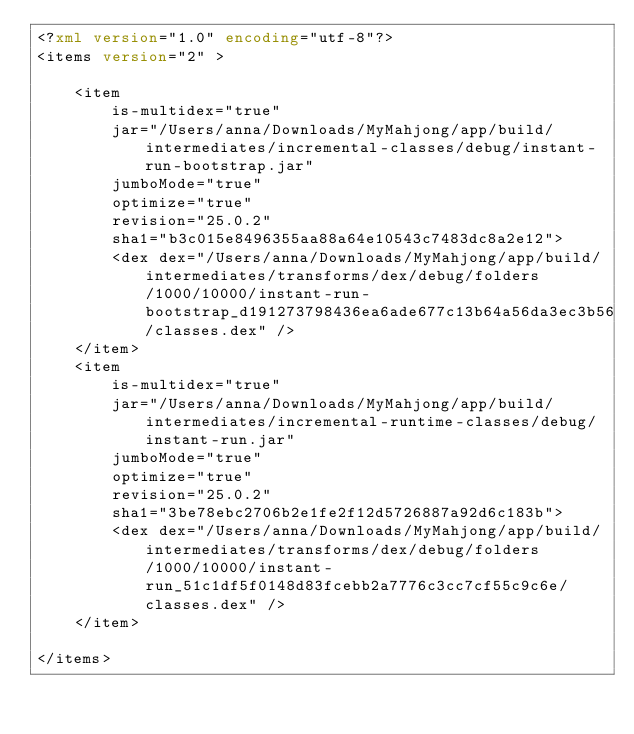Convert code to text. <code><loc_0><loc_0><loc_500><loc_500><_XML_><?xml version="1.0" encoding="utf-8"?>
<items version="2" >

    <item
        is-multidex="true"
        jar="/Users/anna/Downloads/MyMahjong/app/build/intermediates/incremental-classes/debug/instant-run-bootstrap.jar"
        jumboMode="true"
        optimize="true"
        revision="25.0.2"
        sha1="b3c015e8496355aa88a64e10543c7483dc8a2e12">
        <dex dex="/Users/anna/Downloads/MyMahjong/app/build/intermediates/transforms/dex/debug/folders/1000/10000/instant-run-bootstrap_d191273798436ea6ade677c13b64a56da3ec3b56/classes.dex" />
    </item>
    <item
        is-multidex="true"
        jar="/Users/anna/Downloads/MyMahjong/app/build/intermediates/incremental-runtime-classes/debug/instant-run.jar"
        jumboMode="true"
        optimize="true"
        revision="25.0.2"
        sha1="3be78ebc2706b2e1fe2f12d5726887a92d6c183b">
        <dex dex="/Users/anna/Downloads/MyMahjong/app/build/intermediates/transforms/dex/debug/folders/1000/10000/instant-run_51c1df5f0148d83fcebb2a7776c3cc7cf55c9c6e/classes.dex" />
    </item>

</items>
</code> 